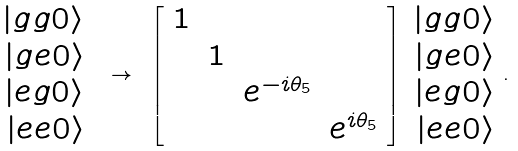Convert formula to latex. <formula><loc_0><loc_0><loc_500><loc_500>\begin{array} { r } | g g 0 \rangle \\ | g e 0 \rangle \\ | e g 0 \rangle \\ | e e 0 \rangle \end{array} \ \rightarrow \ \left [ \begin{array} { c c c c } 1 & & & \\ & 1 & & \\ & & e ^ { - i \theta _ { 5 } } & \\ & & & e ^ { i \theta _ { 5 } } \end{array} \right ] \begin{array} { r } | g g 0 \rangle \\ | g e 0 \rangle \\ | e g 0 \rangle \\ | e e 0 \rangle \end{array} .</formula> 